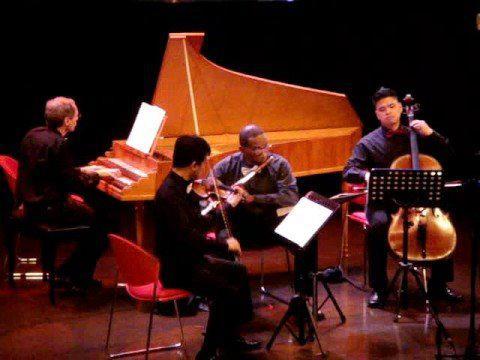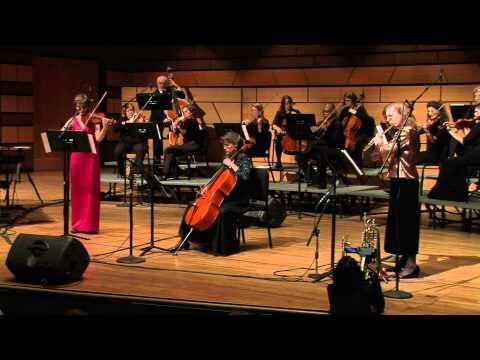The first image is the image on the left, the second image is the image on the right. Assess this claim about the two images: "The image on the left shows an instrumental group with at least four members, and all members sitting on chairs.". Correct or not? Answer yes or no. Yes. 